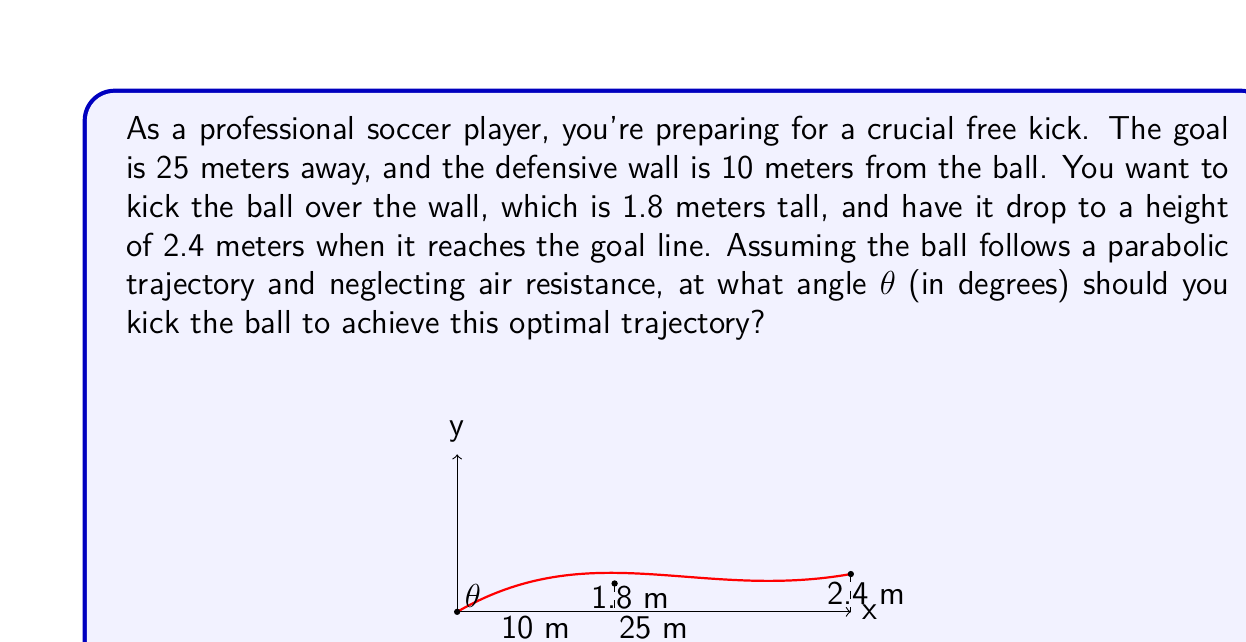Can you solve this math problem? Let's approach this step-by-step using vector projections:

1) First, we need to set up our coordinate system. Let's use the kicking point as the origin (0,0), with the x-axis along the ground towards the goal, and the y-axis vertically upwards.

2) We can represent the trajectory of the ball as a vector from the origin to the goal:
   $$\vec{v} = \langle 25, 2.4 \rangle$$

3) The magnitude of this vector is:
   $$|\vec{v}| = \sqrt{25^2 + 2.4^2} = 25.115$$

4) We need to find the angle θ between this vector and the x-axis. We can do this using the dot product formula:
   $$\cos θ = \frac{\vec{v} \cdot \hat{i}}{|\vec{v}|}$$

   where $\hat{i}$ is the unit vector along the x-axis $\langle 1, 0 \rangle$.

5) Calculating the dot product:
   $$\vec{v} \cdot \hat{i} = 25 \cdot 1 + 2.4 \cdot 0 = 25$$

6) Substituting into the formula:
   $$\cos θ = \frac{25}{25.115} = 0.9954$$

7) Taking the inverse cosine (arccos) of both sides:
   $$θ = \arccos(0.9954) = 0.0959 \text{ radians}$$

8) Converting to degrees:
   $$θ = 0.0959 \cdot \frac{180}{\pi} = 5.49°$$

9) However, this is the angle of the vector to the goal, not the initial kick angle. For a parabolic trajectory, the initial angle should be twice this angle.

Therefore, the optimal kick angle is:
$$θ_{\text{kick}} = 2 \cdot 5.49° = 10.98°$$
Answer: The optimal angle for the free kick is approximately 11° (10.98° to be precise). 